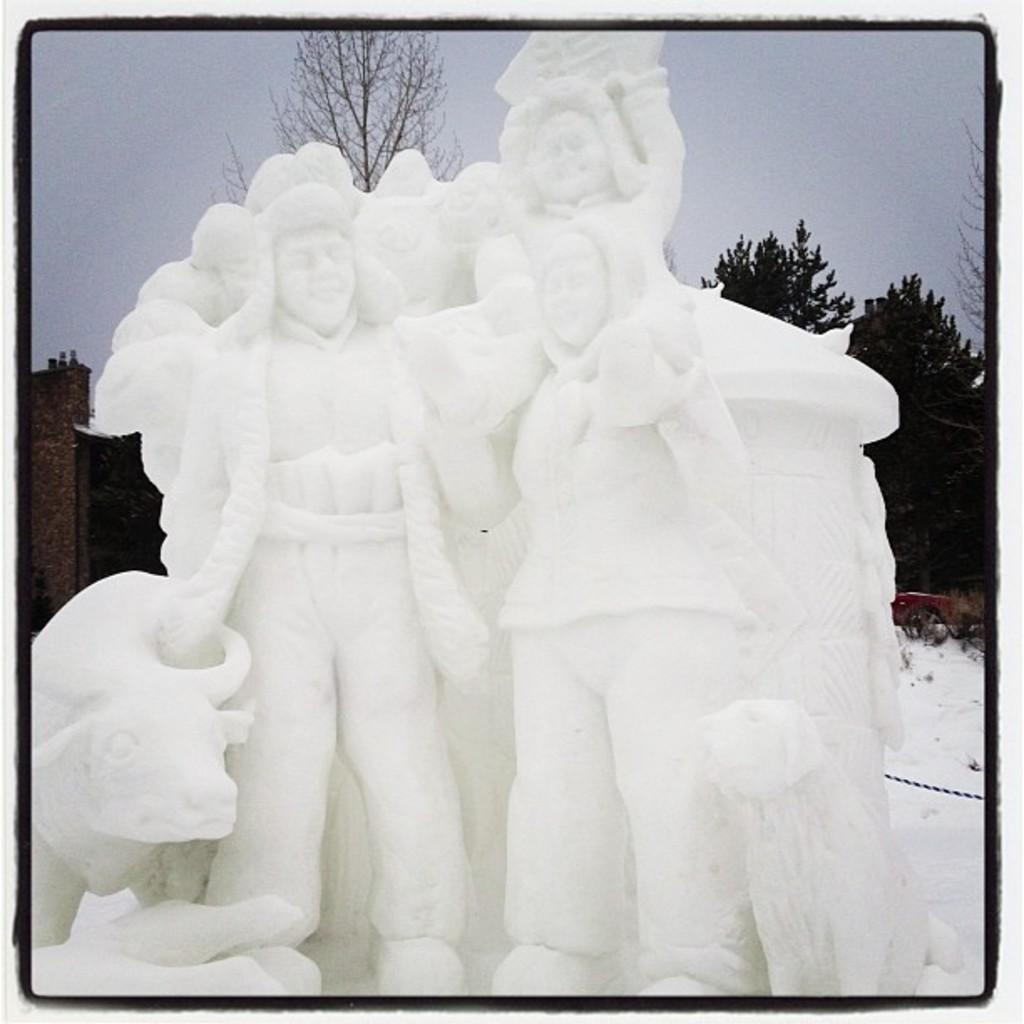What is the main subject in the center of the image? There are statues in the center of the image. What can be seen in the background of the image? There is sky, trees, and snow visible in the background of the image. How many ants can be seen crawling on the statues in the image? There are no ants visible on the statues in the image. What type of branch is holding up the statues in the image? There is no branch present in the image; the statues are not supported by any visible branches. 